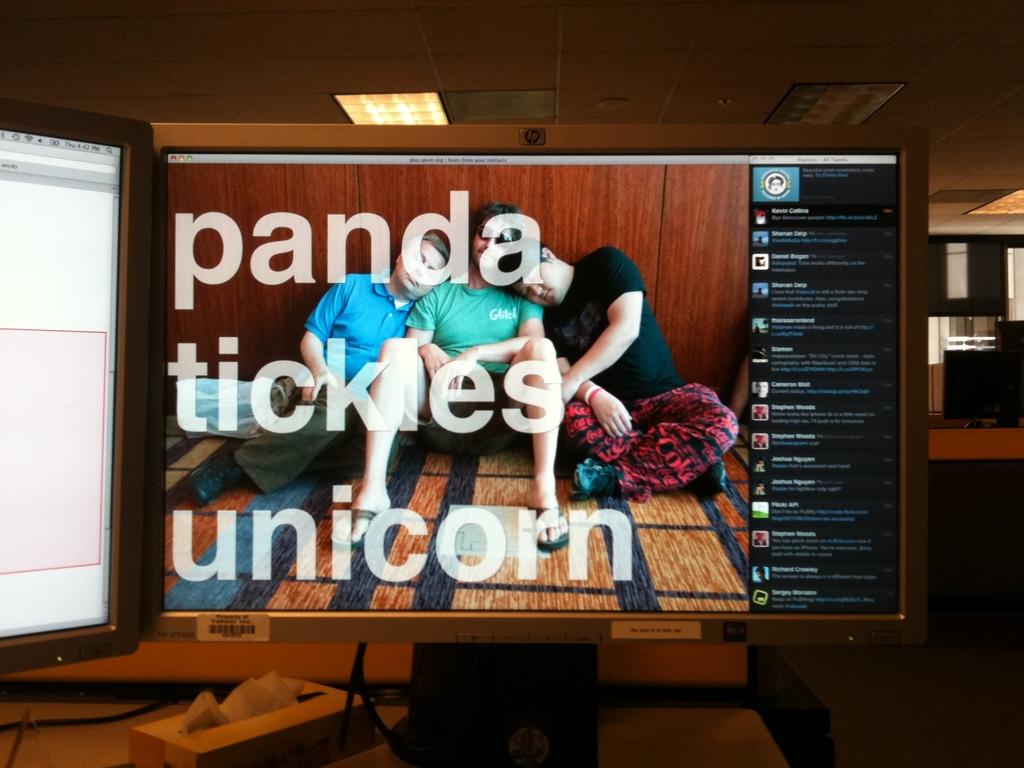What mythological creature gets tickled?
Provide a succinct answer. Unicorn. Is that a movie/?
Offer a very short reply. No. 